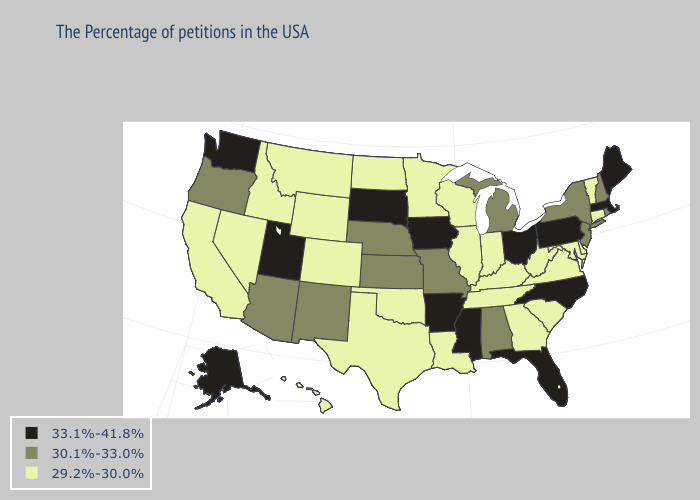What is the lowest value in states that border West Virginia?
Concise answer only. 29.2%-30.0%. Name the states that have a value in the range 33.1%-41.8%?
Quick response, please. Maine, Massachusetts, Pennsylvania, North Carolina, Ohio, Florida, Mississippi, Arkansas, Iowa, South Dakota, Utah, Washington, Alaska. Name the states that have a value in the range 30.1%-33.0%?
Give a very brief answer. Rhode Island, New Hampshire, New York, New Jersey, Michigan, Alabama, Missouri, Kansas, Nebraska, New Mexico, Arizona, Oregon. Which states have the lowest value in the USA?
Concise answer only. Vermont, Connecticut, Delaware, Maryland, Virginia, South Carolina, West Virginia, Georgia, Kentucky, Indiana, Tennessee, Wisconsin, Illinois, Louisiana, Minnesota, Oklahoma, Texas, North Dakota, Wyoming, Colorado, Montana, Idaho, Nevada, California, Hawaii. What is the value of Arkansas?
Short answer required. 33.1%-41.8%. What is the value of Washington?
Give a very brief answer. 33.1%-41.8%. Among the states that border Florida , which have the highest value?
Give a very brief answer. Alabama. Does New Jersey have a higher value than Wyoming?
Give a very brief answer. Yes. Does the map have missing data?
Be succinct. No. What is the value of Vermont?
Quick response, please. 29.2%-30.0%. Does Ohio have the highest value in the MidWest?
Answer briefly. Yes. What is the value of Nevada?
Answer briefly. 29.2%-30.0%. What is the value of Georgia?
Concise answer only. 29.2%-30.0%. What is the highest value in the USA?
Concise answer only. 33.1%-41.8%. Which states have the lowest value in the USA?
Give a very brief answer. Vermont, Connecticut, Delaware, Maryland, Virginia, South Carolina, West Virginia, Georgia, Kentucky, Indiana, Tennessee, Wisconsin, Illinois, Louisiana, Minnesota, Oklahoma, Texas, North Dakota, Wyoming, Colorado, Montana, Idaho, Nevada, California, Hawaii. 